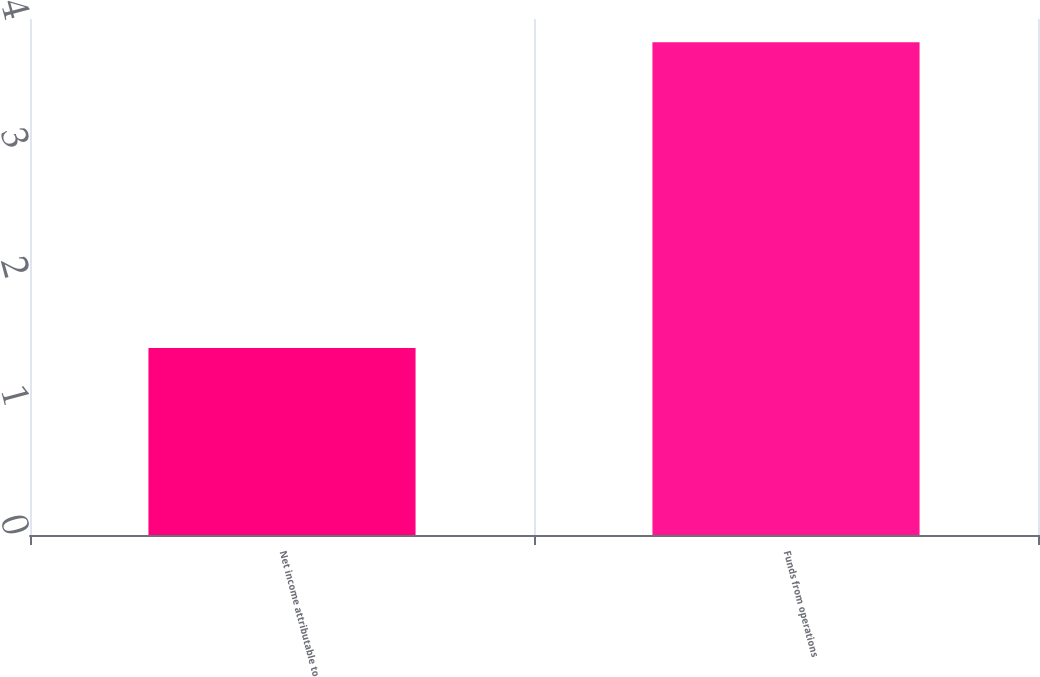Convert chart to OTSL. <chart><loc_0><loc_0><loc_500><loc_500><bar_chart><fcel>Net income attributable to<fcel>Funds from operations<nl><fcel>1.45<fcel>3.82<nl></chart> 